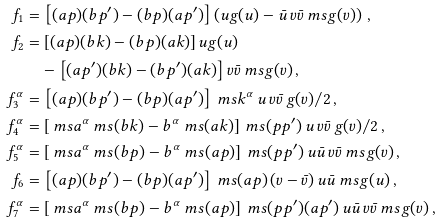Convert formula to latex. <formula><loc_0><loc_0><loc_500><loc_500>f _ { 1 } & = \left [ ( a p ) ( b p ^ { \prime } ) - ( b p ) ( a p ^ { \prime } ) \right ] \left ( u g ( u ) - \bar { u } \, v \bar { v } \ m s g ( v ) \right ) \, , \\ f _ { 2 } & = \left [ ( a p ) ( b k ) - ( b p ) ( a k ) \right ] u g ( u ) \\ & \quad - \left [ ( a p ^ { \prime } ) ( b k ) - ( b p ^ { \prime } ) ( a k ) \right ] v \bar { v } \ m s g ( v ) \, , \\ f _ { 3 } ^ { \alpha } & = \left [ ( a p ) ( b p ^ { \prime } ) - ( b p ) ( a p ^ { \prime } ) \right ] \ m s k ^ { \alpha } \, { u \, v \bar { v } } \, g ( v ) / { 2 } \, , \\ f _ { 4 } ^ { \alpha } & = \left [ \ m s a ^ { \alpha } \ m s ( b k ) - b ^ { \alpha } \ m s ( a k ) \right ] \ m s ( p p ^ { \prime } ) \, { u \, v \bar { v } } \, g ( v ) / { 2 } \, , \\ f _ { 5 } ^ { \alpha } & = \left [ \ m s a ^ { \alpha } \ m s ( b p ) - b ^ { \alpha } \ m s ( a p ) \right ] \ m s ( p p ^ { \prime } ) \, u \bar { u } \, v \bar { v } \ m s g ( v ) \, , \\ f _ { 6 } & = \left [ ( a p ) ( b p ^ { \prime } ) - ( b p ) ( a p ^ { \prime } ) \right ] \ m s ( a p ) \, ( v - \bar { v } ) \, u \bar { u } \ m s g ( u ) \, , \\ f _ { 7 } ^ { \alpha } & = \left [ \ m s a ^ { \alpha } \ m s ( b p ) - b ^ { \alpha } \ m s ( a p ) \right ] \ m s ( p p ^ { \prime } ) ( a p ^ { \prime } ) \, u \bar { u } \, v \bar { v } \ m s g ( v ) \, ,</formula> 